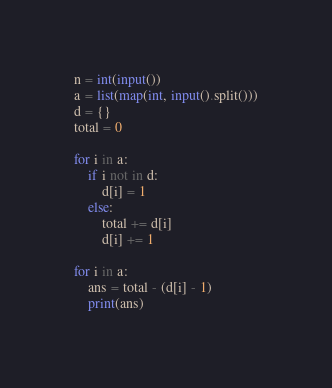<code> <loc_0><loc_0><loc_500><loc_500><_Python_>n = int(input())
a = list(map(int, input().split()))
d = {}
total = 0

for i in a:
    if i not in d:
        d[i] = 1
    else:
        total += d[i]
        d[i] += 1

for i in a:
    ans = total - (d[i] - 1)
    print(ans)</code> 